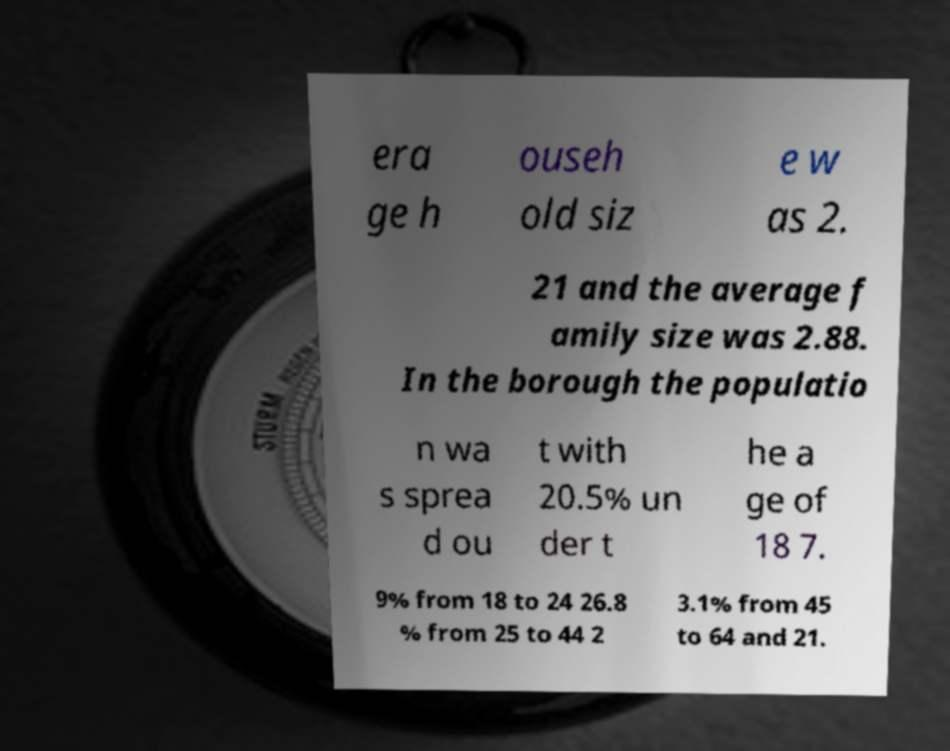Can you accurately transcribe the text from the provided image for me? era ge h ouseh old siz e w as 2. 21 and the average f amily size was 2.88. In the borough the populatio n wa s sprea d ou t with 20.5% un der t he a ge of 18 7. 9% from 18 to 24 26.8 % from 25 to 44 2 3.1% from 45 to 64 and 21. 